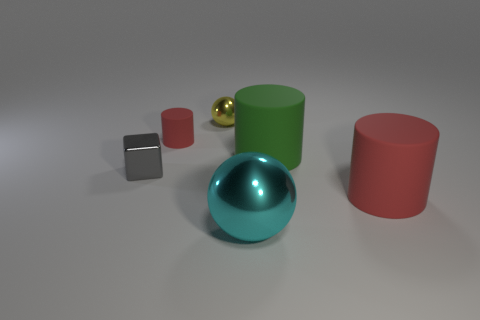What size is the rubber object that is the same color as the small rubber cylinder?
Offer a terse response. Large. Do the yellow metallic object and the big cyan object right of the small cylinder have the same shape?
Offer a terse response. Yes. The large cylinder that is to the left of the rubber thing that is in front of the small metallic thing that is in front of the tiny matte object is made of what material?
Your answer should be compact. Rubber. How many tiny gray rubber balls are there?
Offer a very short reply. 0. How many purple things are either large shiny balls or small cubes?
Offer a terse response. 0. How many other objects are the same shape as the small gray thing?
Give a very brief answer. 0. Is the color of the small matte cylinder left of the large red thing the same as the large rubber thing in front of the small gray metal thing?
Offer a very short reply. Yes. How many tiny things are yellow balls or rubber things?
Your answer should be compact. 2. What is the size of the cyan object that is the same shape as the yellow thing?
Provide a short and direct response. Large. The red cylinder that is to the right of the red matte thing on the left side of the yellow metal ball is made of what material?
Provide a short and direct response. Rubber. 